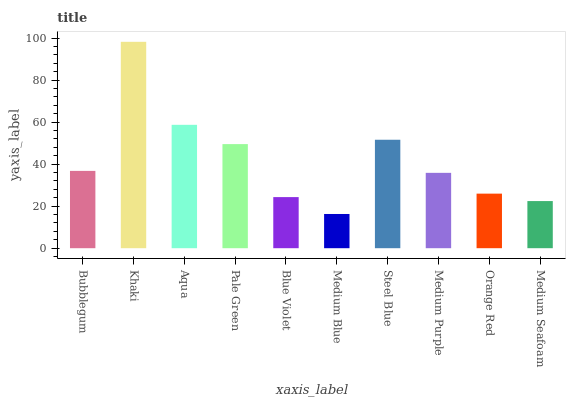Is Medium Blue the minimum?
Answer yes or no. Yes. Is Khaki the maximum?
Answer yes or no. Yes. Is Aqua the minimum?
Answer yes or no. No. Is Aqua the maximum?
Answer yes or no. No. Is Khaki greater than Aqua?
Answer yes or no. Yes. Is Aqua less than Khaki?
Answer yes or no. Yes. Is Aqua greater than Khaki?
Answer yes or no. No. Is Khaki less than Aqua?
Answer yes or no. No. Is Bubblegum the high median?
Answer yes or no. Yes. Is Medium Purple the low median?
Answer yes or no. Yes. Is Aqua the high median?
Answer yes or no. No. Is Medium Seafoam the low median?
Answer yes or no. No. 